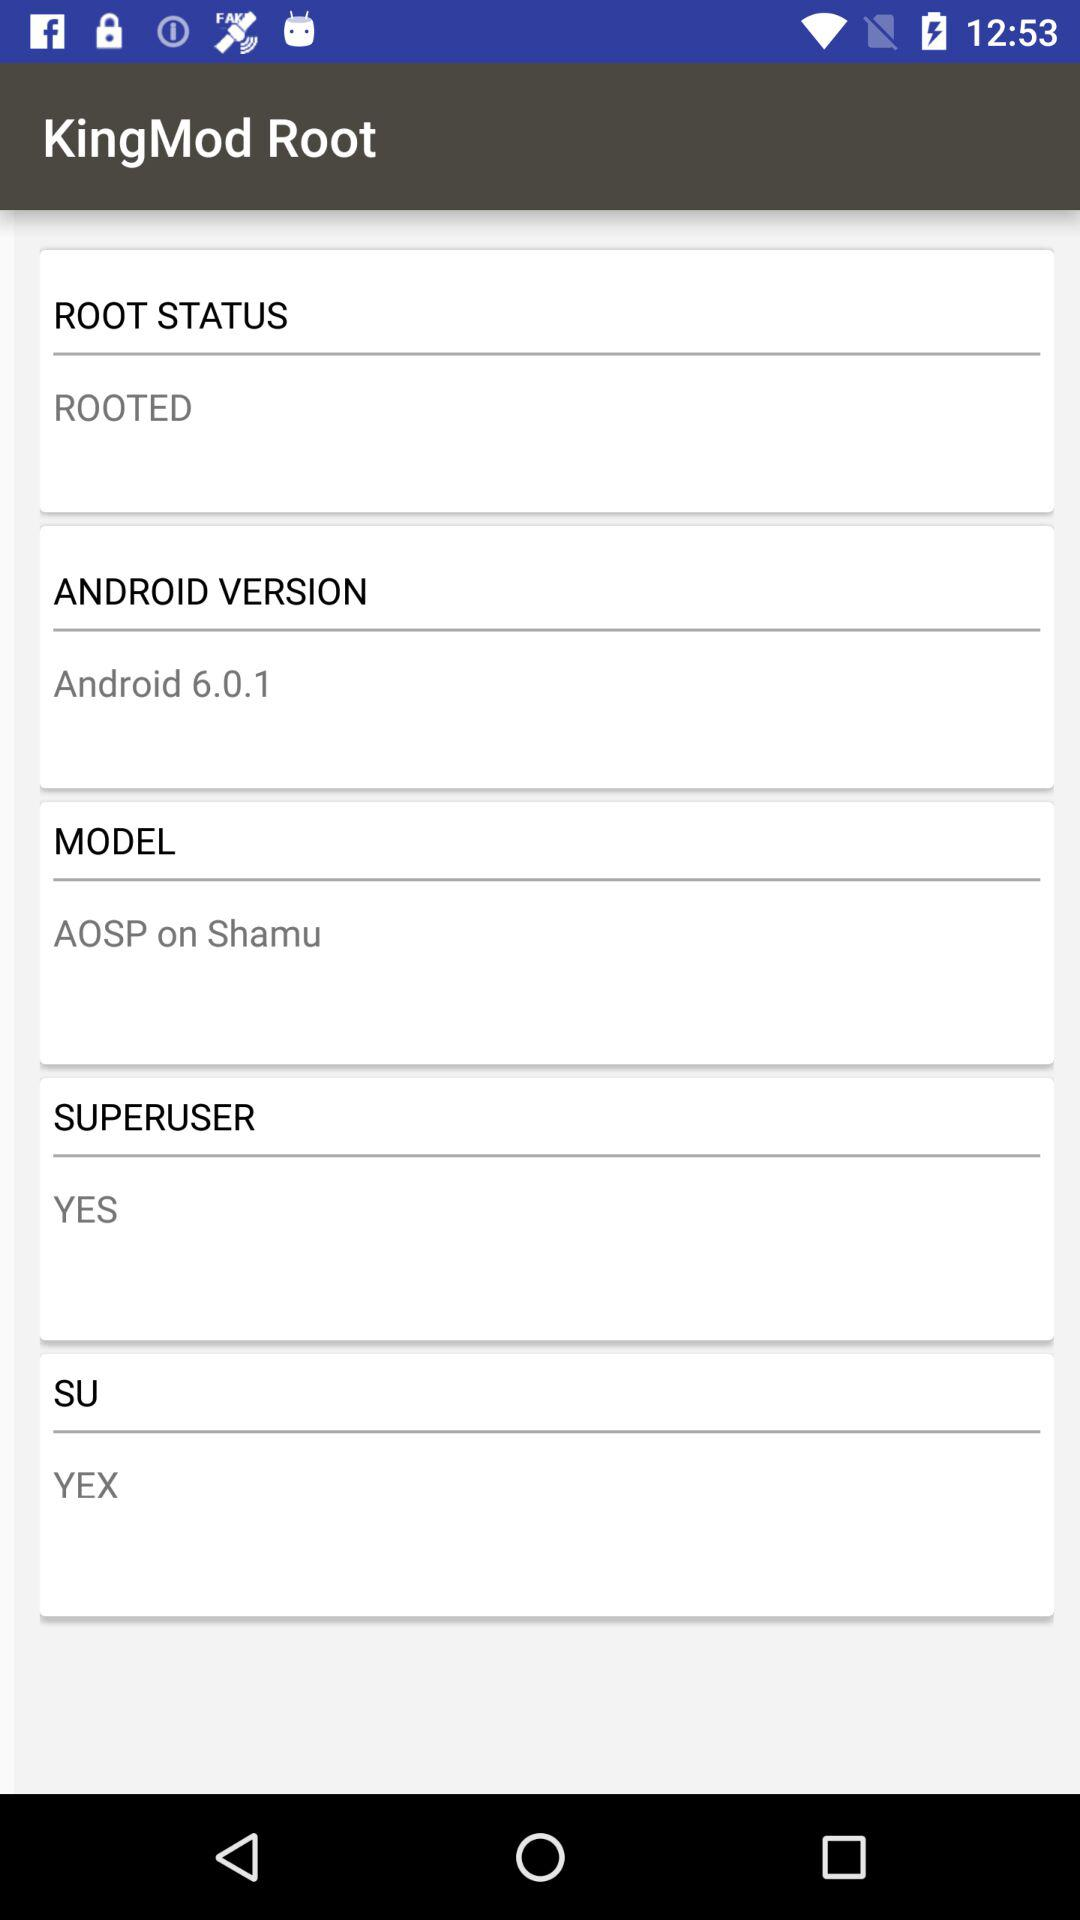What is the model of "KingMod Root"? The model of "KingMod Root" is AOSP on Shamu. 